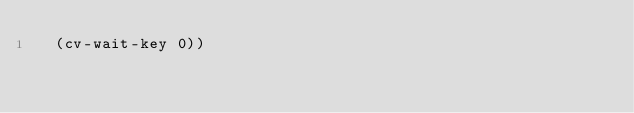<code> <loc_0><loc_0><loc_500><loc_500><_Scheme_>  (cv-wait-key 0))





</code> 